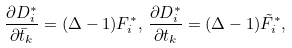<formula> <loc_0><loc_0><loc_500><loc_500>\frac { \partial D ^ { * } _ { i } } { \partial \bar { t } _ { k } } = ( \Delta - 1 ) F ^ { * } _ { i } , \, \frac { \partial D _ { i } ^ { * } } { \partial t _ { k } } = ( \Delta - 1 ) \tilde { F } ^ { * } _ { i } ,</formula> 